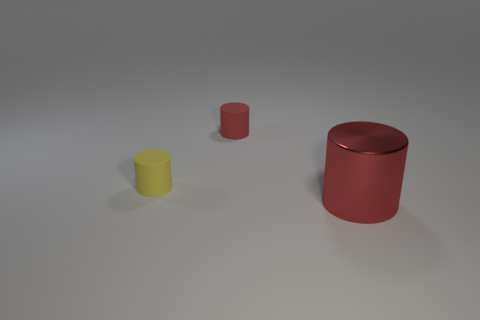Add 1 large red cylinders. How many objects exist? 4 Add 3 small red matte objects. How many small red matte objects are left? 4 Add 2 big green rubber cylinders. How many big green rubber cylinders exist? 2 Subtract 0 brown cylinders. How many objects are left? 3 Subtract all small cylinders. Subtract all small yellow things. How many objects are left? 0 